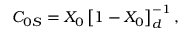Convert formula to latex. <formula><loc_0><loc_0><loc_500><loc_500>C _ { 0 S } = X _ { 0 } \left [ 1 - X _ { 0 } \right ] _ { d } ^ { - 1 } ,</formula> 